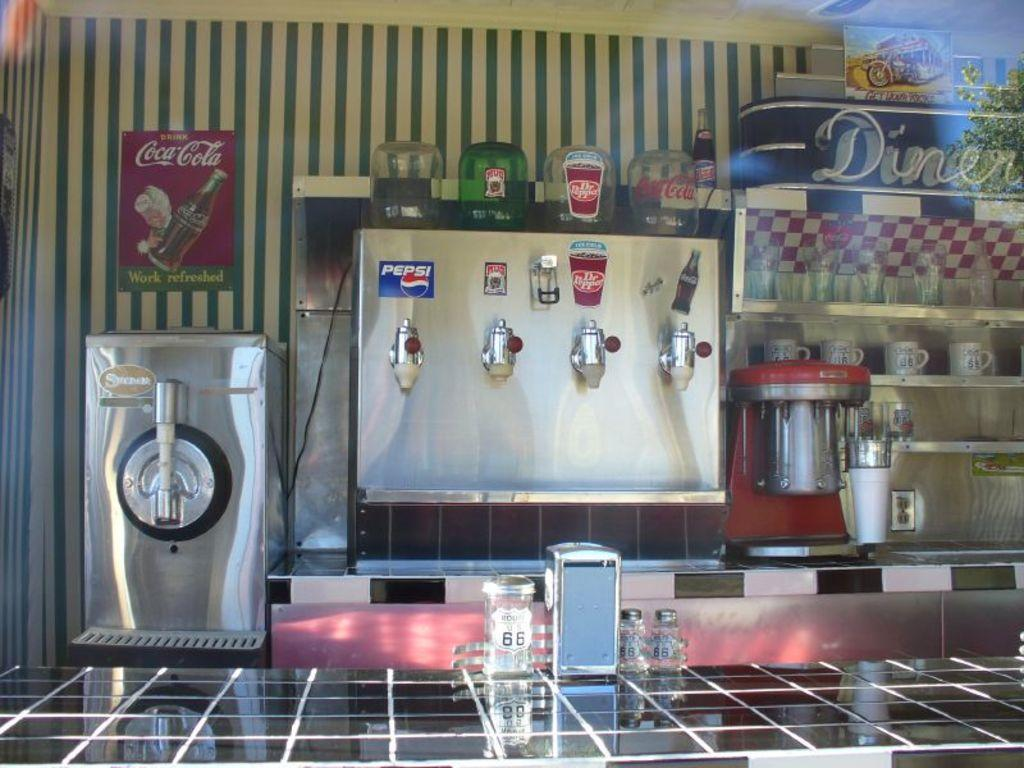<image>
Create a compact narrative representing the image presented. Diner showing a soda machine along the counter. 